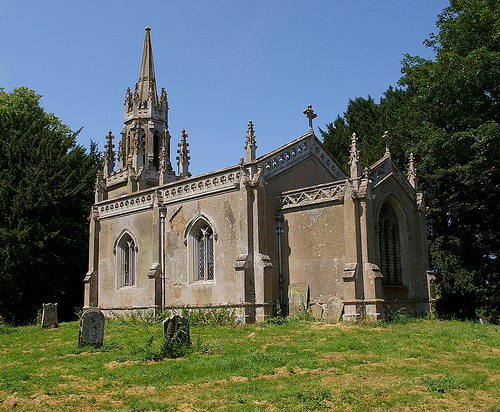<image>
Can you confirm if the church is in front of the headstone? No. The church is not in front of the headstone. The spatial positioning shows a different relationship between these objects. 